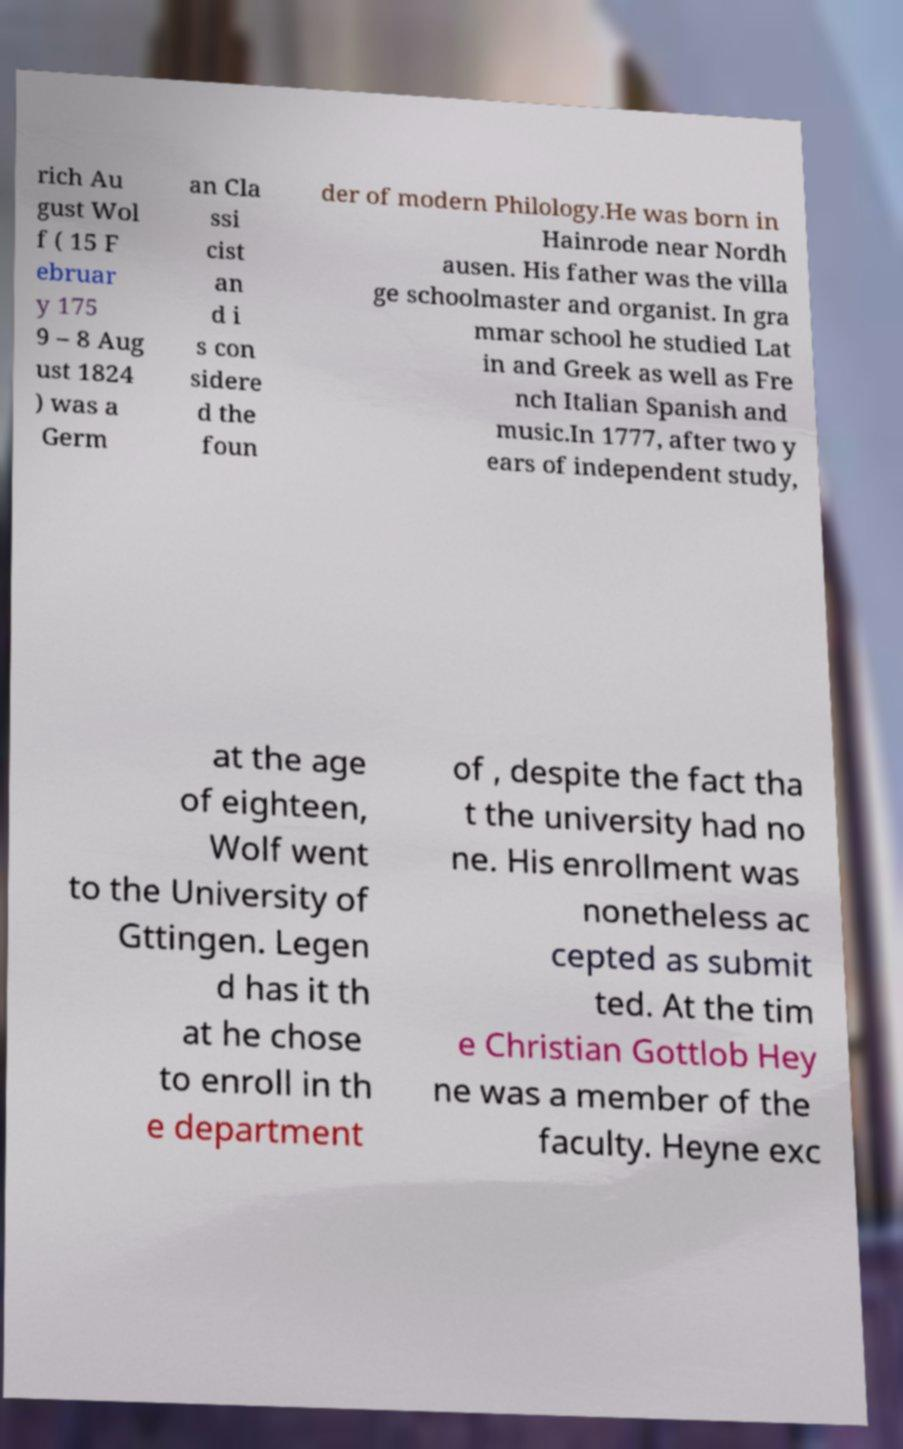What messages or text are displayed in this image? I need them in a readable, typed format. rich Au gust Wol f ( 15 F ebruar y 175 9 – 8 Aug ust 1824 ) was a Germ an Cla ssi cist an d i s con sidere d the foun der of modern Philology.He was born in Hainrode near Nordh ausen. His father was the villa ge schoolmaster and organist. In gra mmar school he studied Lat in and Greek as well as Fre nch Italian Spanish and music.In 1777, after two y ears of independent study, at the age of eighteen, Wolf went to the University of Gttingen. Legen d has it th at he chose to enroll in th e department of , despite the fact tha t the university had no ne. His enrollment was nonetheless ac cepted as submit ted. At the tim e Christian Gottlob Hey ne was a member of the faculty. Heyne exc 